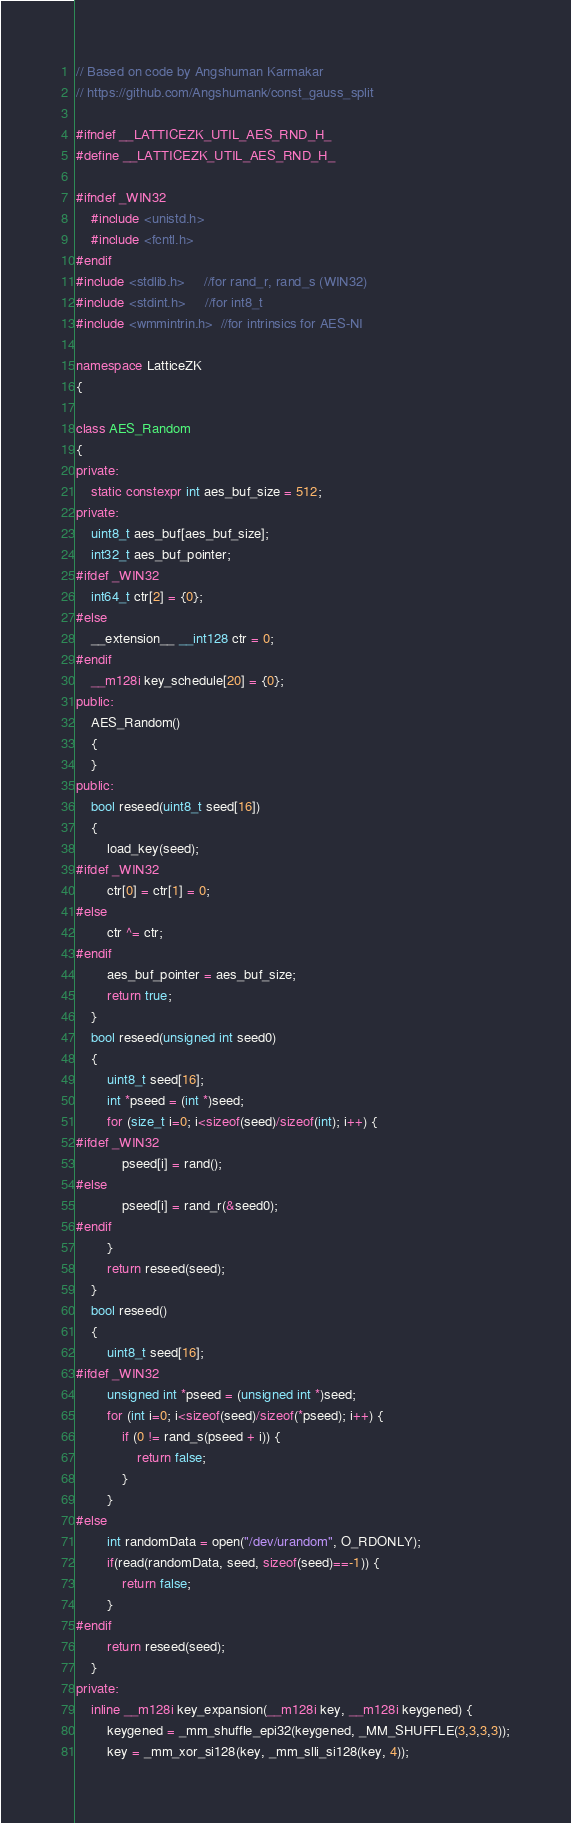<code> <loc_0><loc_0><loc_500><loc_500><_C++_>// Based on code by Angshuman Karmakar
// https://github.com/Angshumank/const_gauss_split

#ifndef __LATTICEZK_UTIL_AES_RND_H_
#define __LATTICEZK_UTIL_AES_RND_H_

#ifndef _WIN32
	#include <unistd.h>
	#include <fcntl.h>
#endif
#include <stdlib.h>     //for rand_r, rand_s (WIN32)
#include <stdint.h>     //for int8_t
#include <wmmintrin.h>  //for intrinsics for AES-NI

namespace LatticeZK
{

class AES_Random
{
private:
	static constexpr int aes_buf_size = 512;
private:
	uint8_t aes_buf[aes_buf_size];
	int32_t aes_buf_pointer;
#ifdef _WIN32
	int64_t ctr[2] = {0};
#else
	__extension__ __int128 ctr = 0;
#endif
	__m128i key_schedule[20] = {0};
public:
	AES_Random()
	{
	}
public:
	bool reseed(uint8_t seed[16])
	{
		load_key(seed);
#ifdef _WIN32
		ctr[0] = ctr[1] = 0;
#else
		ctr ^= ctr;
#endif
		aes_buf_pointer = aes_buf_size;
		return true;
	}
	bool reseed(unsigned int seed0)
	{
		uint8_t seed[16];
		int *pseed = (int *)seed;
		for (size_t i=0; i<sizeof(seed)/sizeof(int); i++) {
#ifdef _WIN32
			pseed[i] = rand();
#else
			pseed[i] = rand_r(&seed0);
#endif
		}
		return reseed(seed);
	}
	bool reseed()
	{
		uint8_t seed[16];
#ifdef _WIN32
		unsigned int *pseed = (unsigned int *)seed;
		for (int i=0; i<sizeof(seed)/sizeof(*pseed); i++) {
			if (0 != rand_s(pseed + i)) {
				return false;
			}
		}
#else
		int randomData = open("/dev/urandom", O_RDONLY);
		if(read(randomData, seed, sizeof(seed)==-1)) {
			return false;
		}
#endif
		return reseed(seed);
	}
private:
	inline __m128i key_expansion(__m128i key, __m128i keygened) {
	    keygened = _mm_shuffle_epi32(keygened, _MM_SHUFFLE(3,3,3,3));
	    key = _mm_xor_si128(key, _mm_slli_si128(key, 4));</code> 